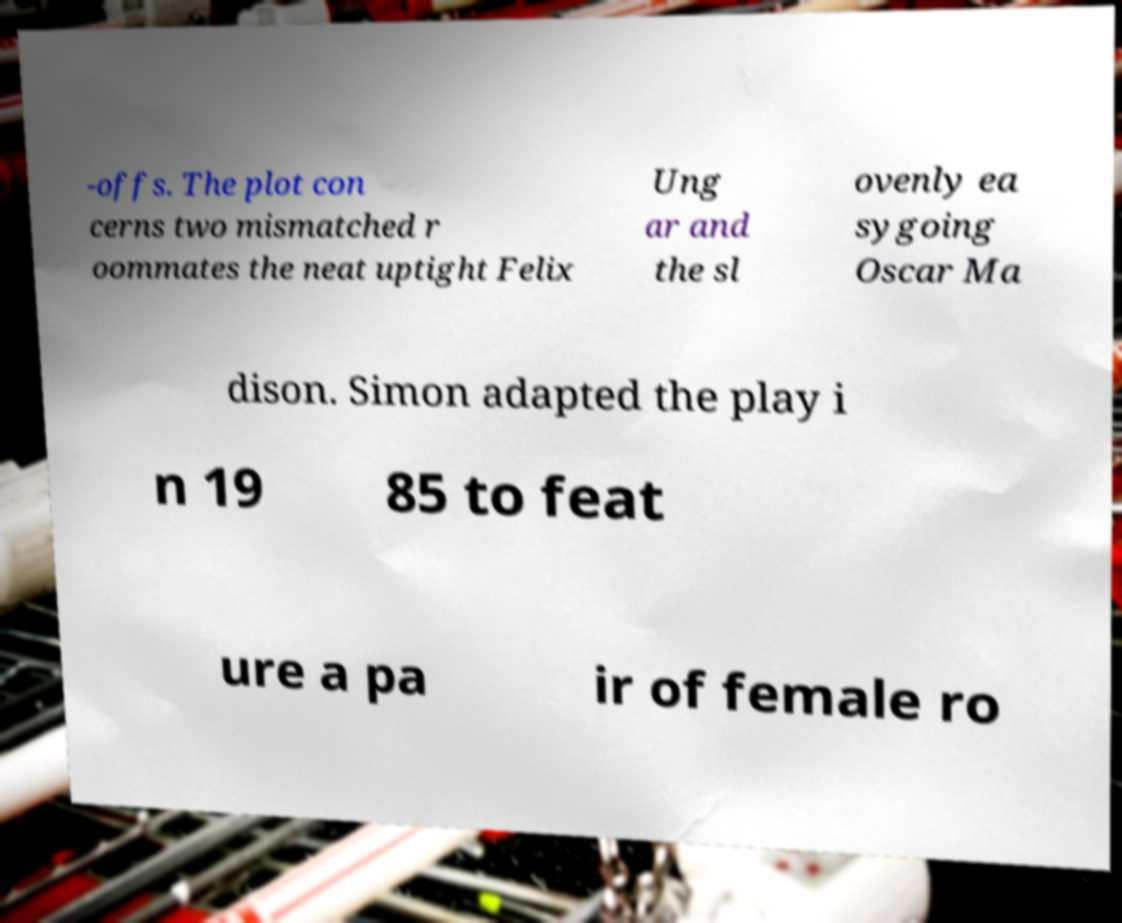Please identify and transcribe the text found in this image. -offs. The plot con cerns two mismatched r oommates the neat uptight Felix Ung ar and the sl ovenly ea sygoing Oscar Ma dison. Simon adapted the play i n 19 85 to feat ure a pa ir of female ro 